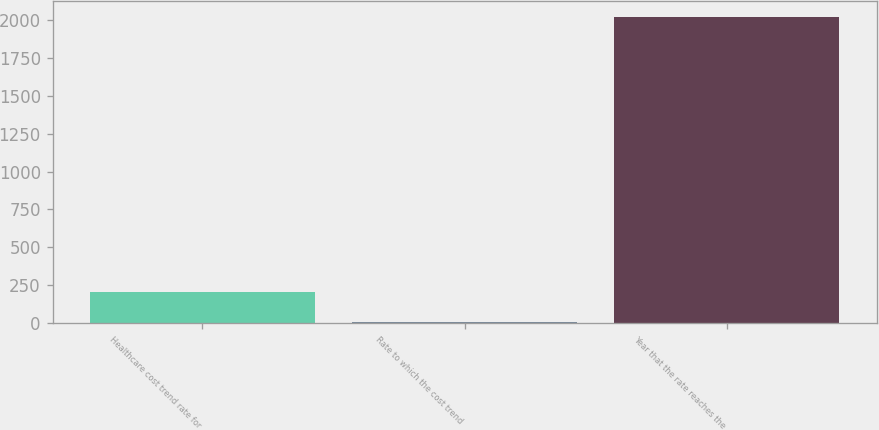Convert chart to OTSL. <chart><loc_0><loc_0><loc_500><loc_500><bar_chart><fcel>Healthcare cost trend rate for<fcel>Rate to which the cost trend<fcel>Year that the rate reaches the<nl><fcel>206.6<fcel>5<fcel>2021<nl></chart> 